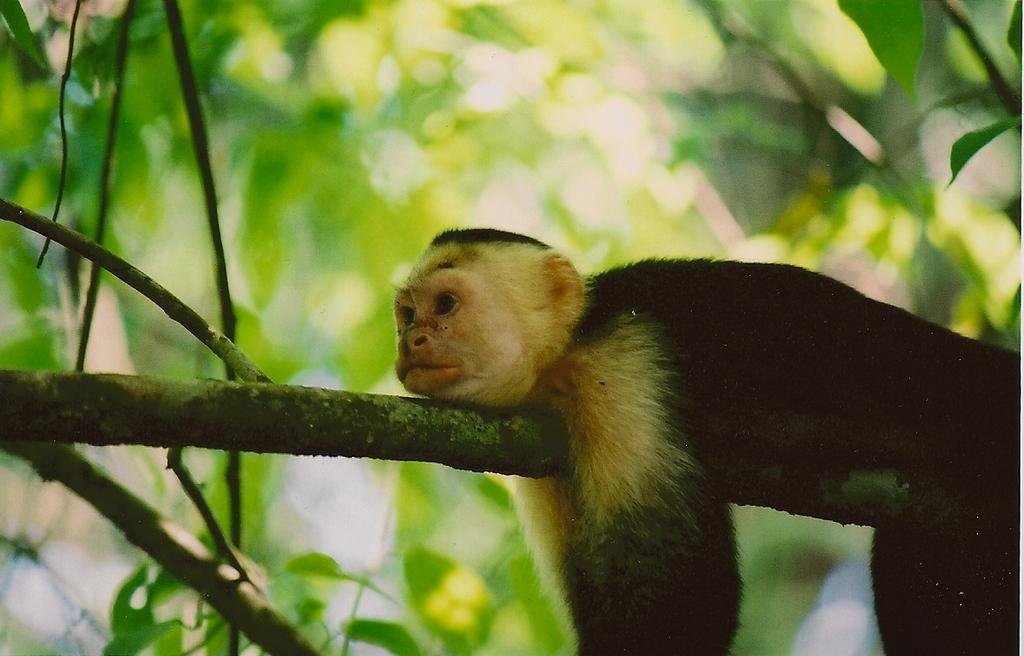What can be observed about the background of the image? The background of the image is blurred. What is the animal doing in the image? There is an animal lying on a branch in the image. What type of vegetation is present in the image? Green leaves are visible in the image. What else can be seen in the image besides the animal and leaves? There are branches present in the image. Can you see any cobwebs in the image? There is no mention of cobwebs in the provided facts, so we cannot determine if any are present in the image. 